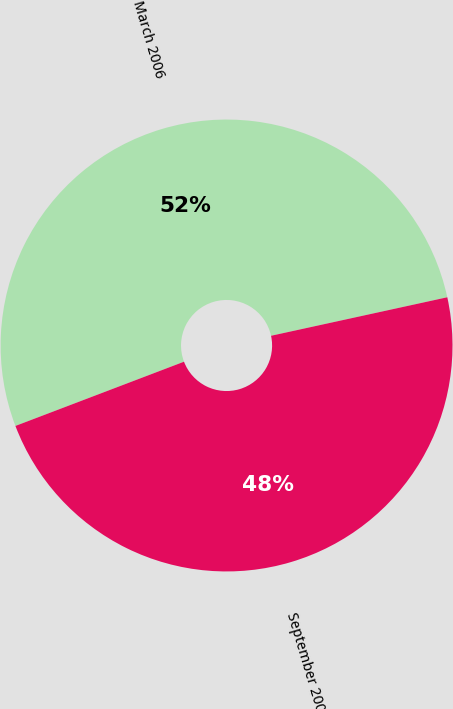Convert chart to OTSL. <chart><loc_0><loc_0><loc_500><loc_500><pie_chart><fcel>March 2006<fcel>September 2008<nl><fcel>52.37%<fcel>47.63%<nl></chart> 